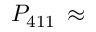Convert formula to latex. <formula><loc_0><loc_0><loc_500><loc_500>P _ { 4 1 1 } \, \approx</formula> 